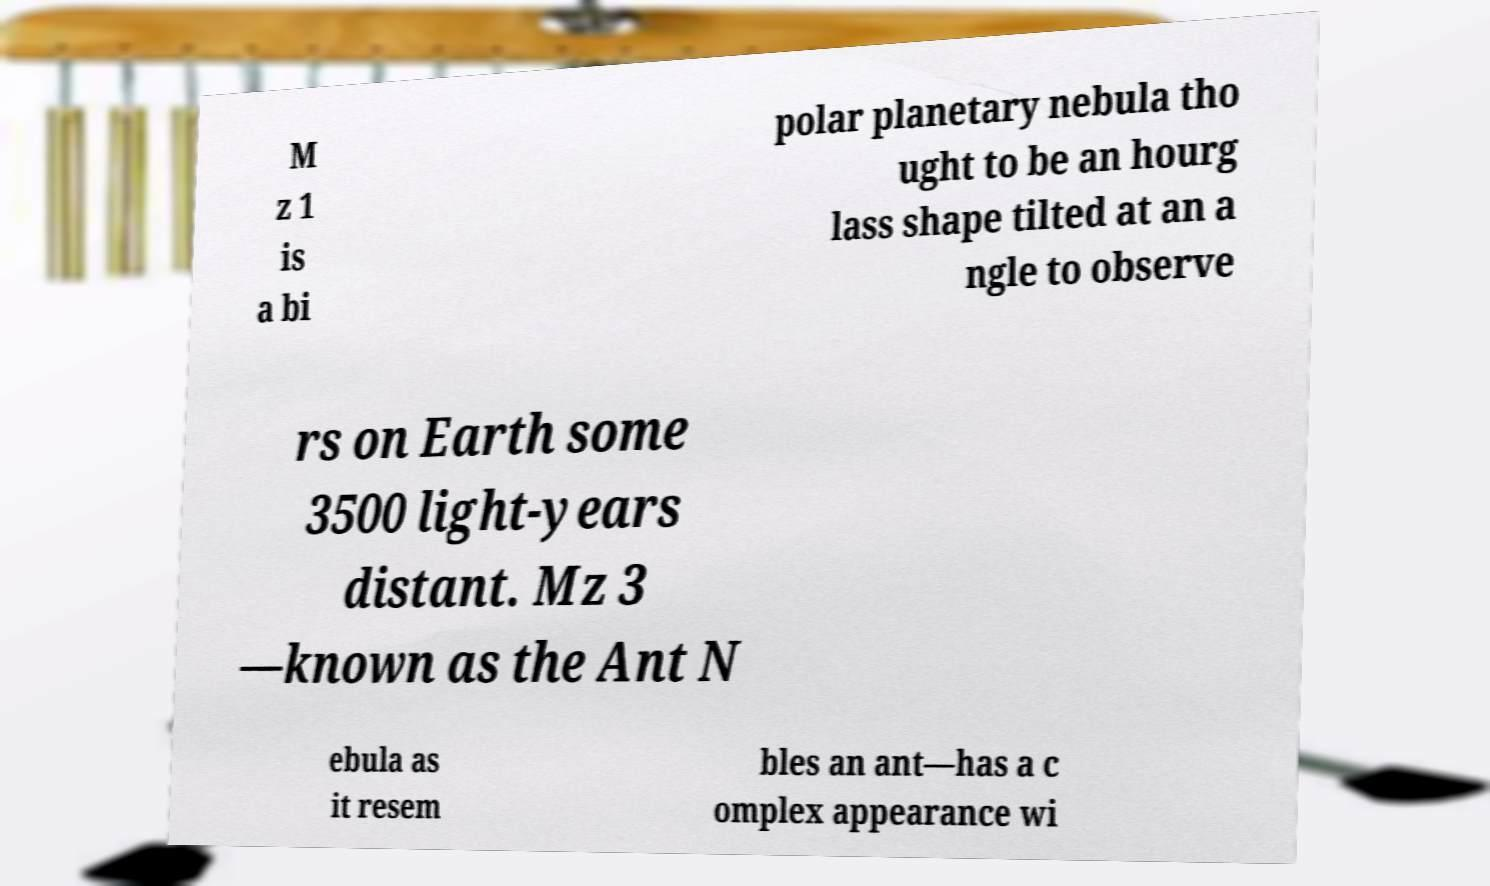What messages or text are displayed in this image? I need them in a readable, typed format. M z 1 is a bi polar planetary nebula tho ught to be an hourg lass shape tilted at an a ngle to observe rs on Earth some 3500 light-years distant. Mz 3 —known as the Ant N ebula as it resem bles an ant—has a c omplex appearance wi 